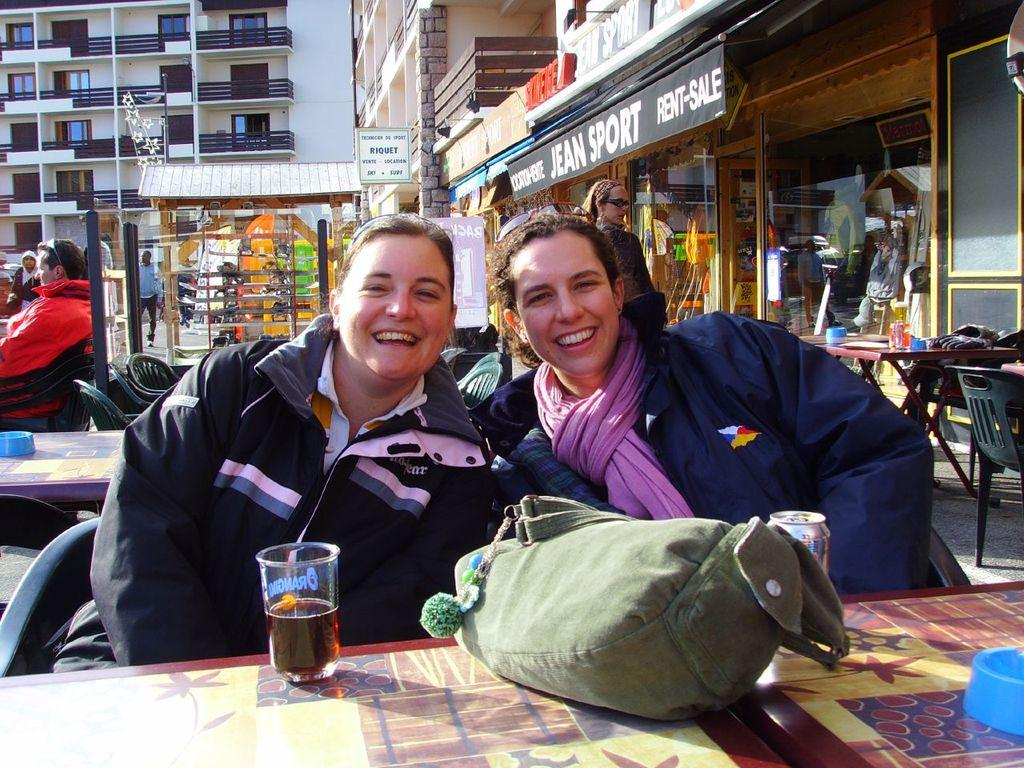How many women are in the image? There are two women in the image. What are the women doing in the image? The women are sitting at a table. What objects can be seen on the table? There is a glass, a tin, and a bag on the table. What can be seen in the background of the image? There are buildings, tables, chairs, and glass doors in the background of the image. Are there any other people visible in the image? Yes, there are people in the background of the image. What type of smoke can be seen coming from the library in the image? There is no library or smoke present in the image. What type of amusement can be seen in the background of the image? There is no amusement depicted in the image; it features a scene with two women sitting at a table and a background with buildings, tables, chairs, and glass doors. 